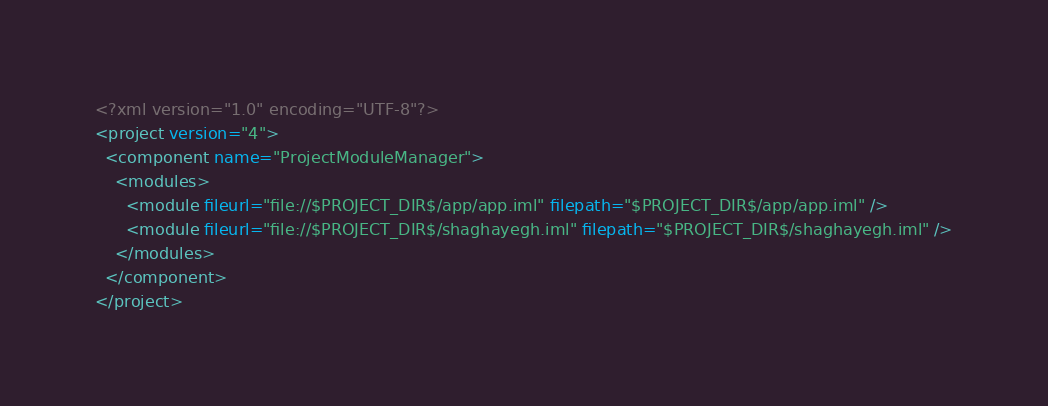<code> <loc_0><loc_0><loc_500><loc_500><_XML_><?xml version="1.0" encoding="UTF-8"?>
<project version="4">
  <component name="ProjectModuleManager">
    <modules>
      <module fileurl="file://$PROJECT_DIR$/app/app.iml" filepath="$PROJECT_DIR$/app/app.iml" />
      <module fileurl="file://$PROJECT_DIR$/shaghayegh.iml" filepath="$PROJECT_DIR$/shaghayegh.iml" />
    </modules>
  </component>
</project></code> 